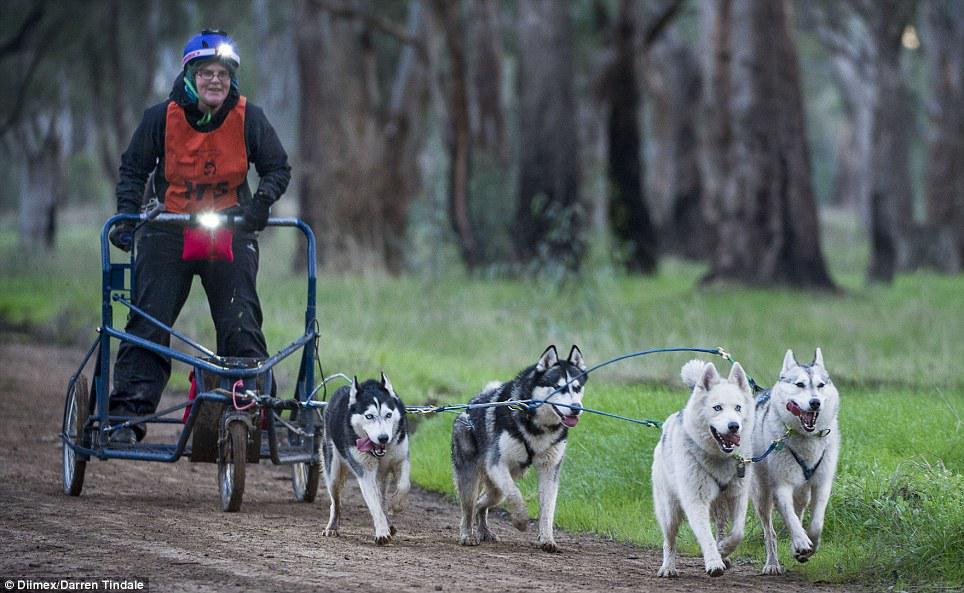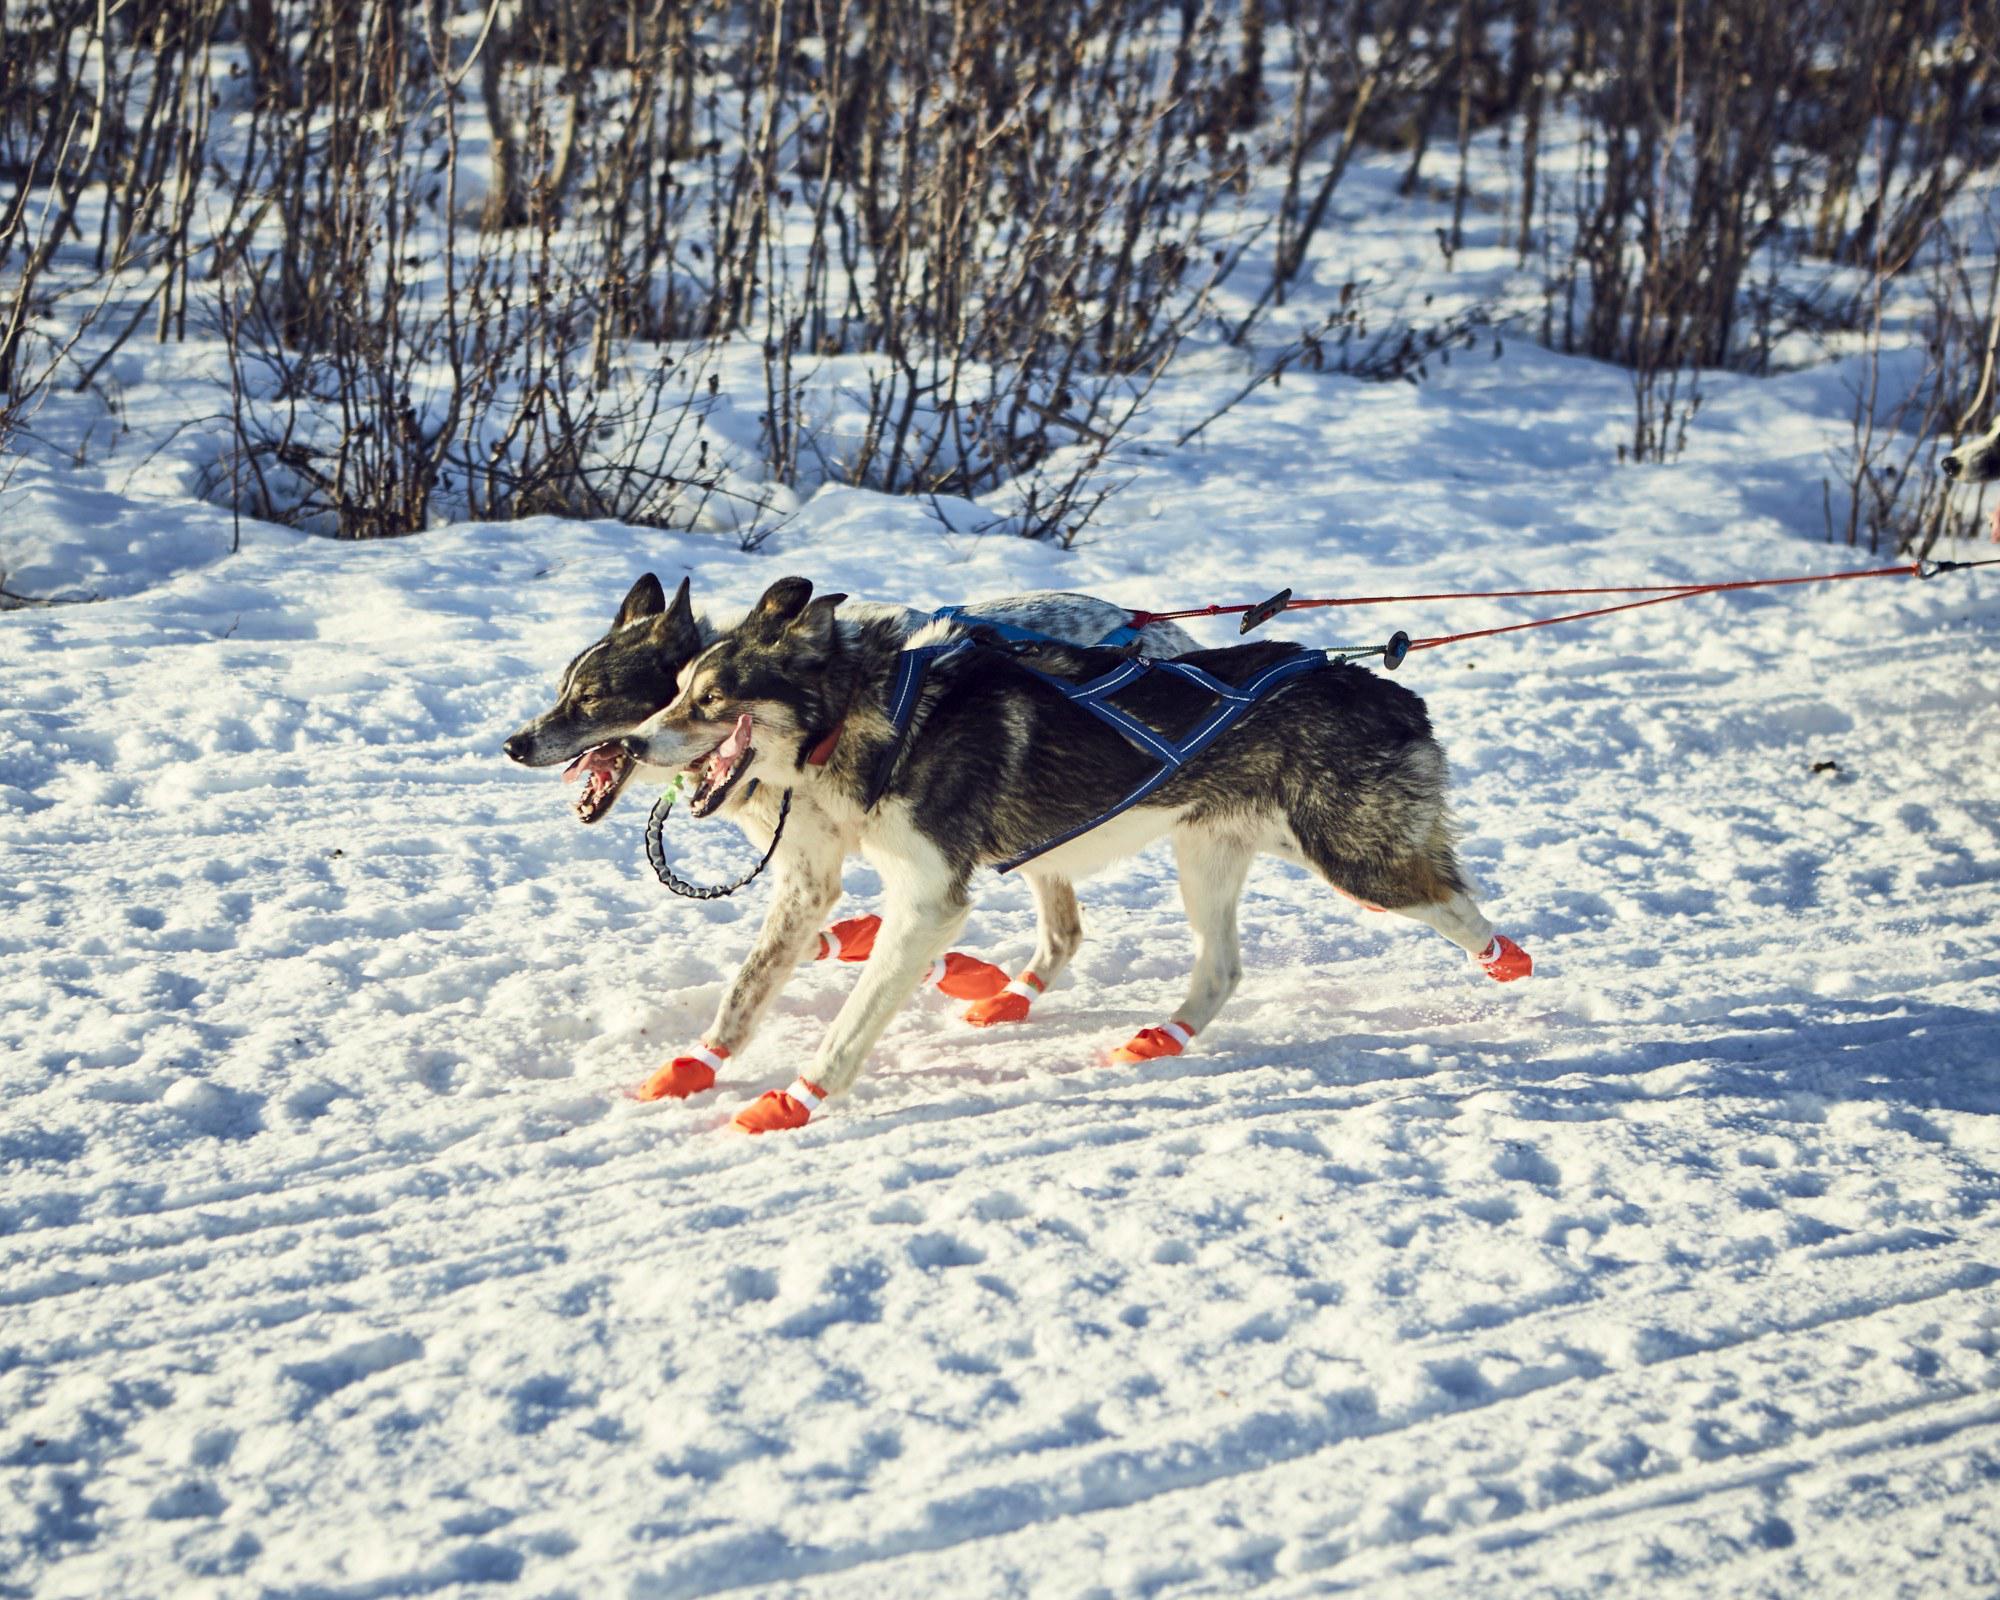The first image is the image on the left, the second image is the image on the right. Assess this claim about the two images: "Less than three dogs are visible in one of the images.". Correct or not? Answer yes or no. Yes. The first image is the image on the left, the second image is the image on the right. For the images displayed, is the sentence "One image shows no more than two harnessed dogs, which are moving across the snow." factually correct? Answer yes or no. Yes. 